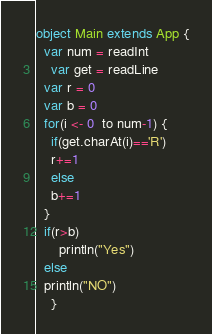Convert code to text. <code><loc_0><loc_0><loc_500><loc_500><_Scala_>object Main extends App {
  var num = readInt
    var get = readLine
  var r = 0
  var b = 0
  for(i <- 0  to num-1) {
    if(get.charAt(i)=='R')
    r+=1
    else
    b+=1
  }
  if(r>b)
      println("Yes")
  else
  println("NO")
    }</code> 